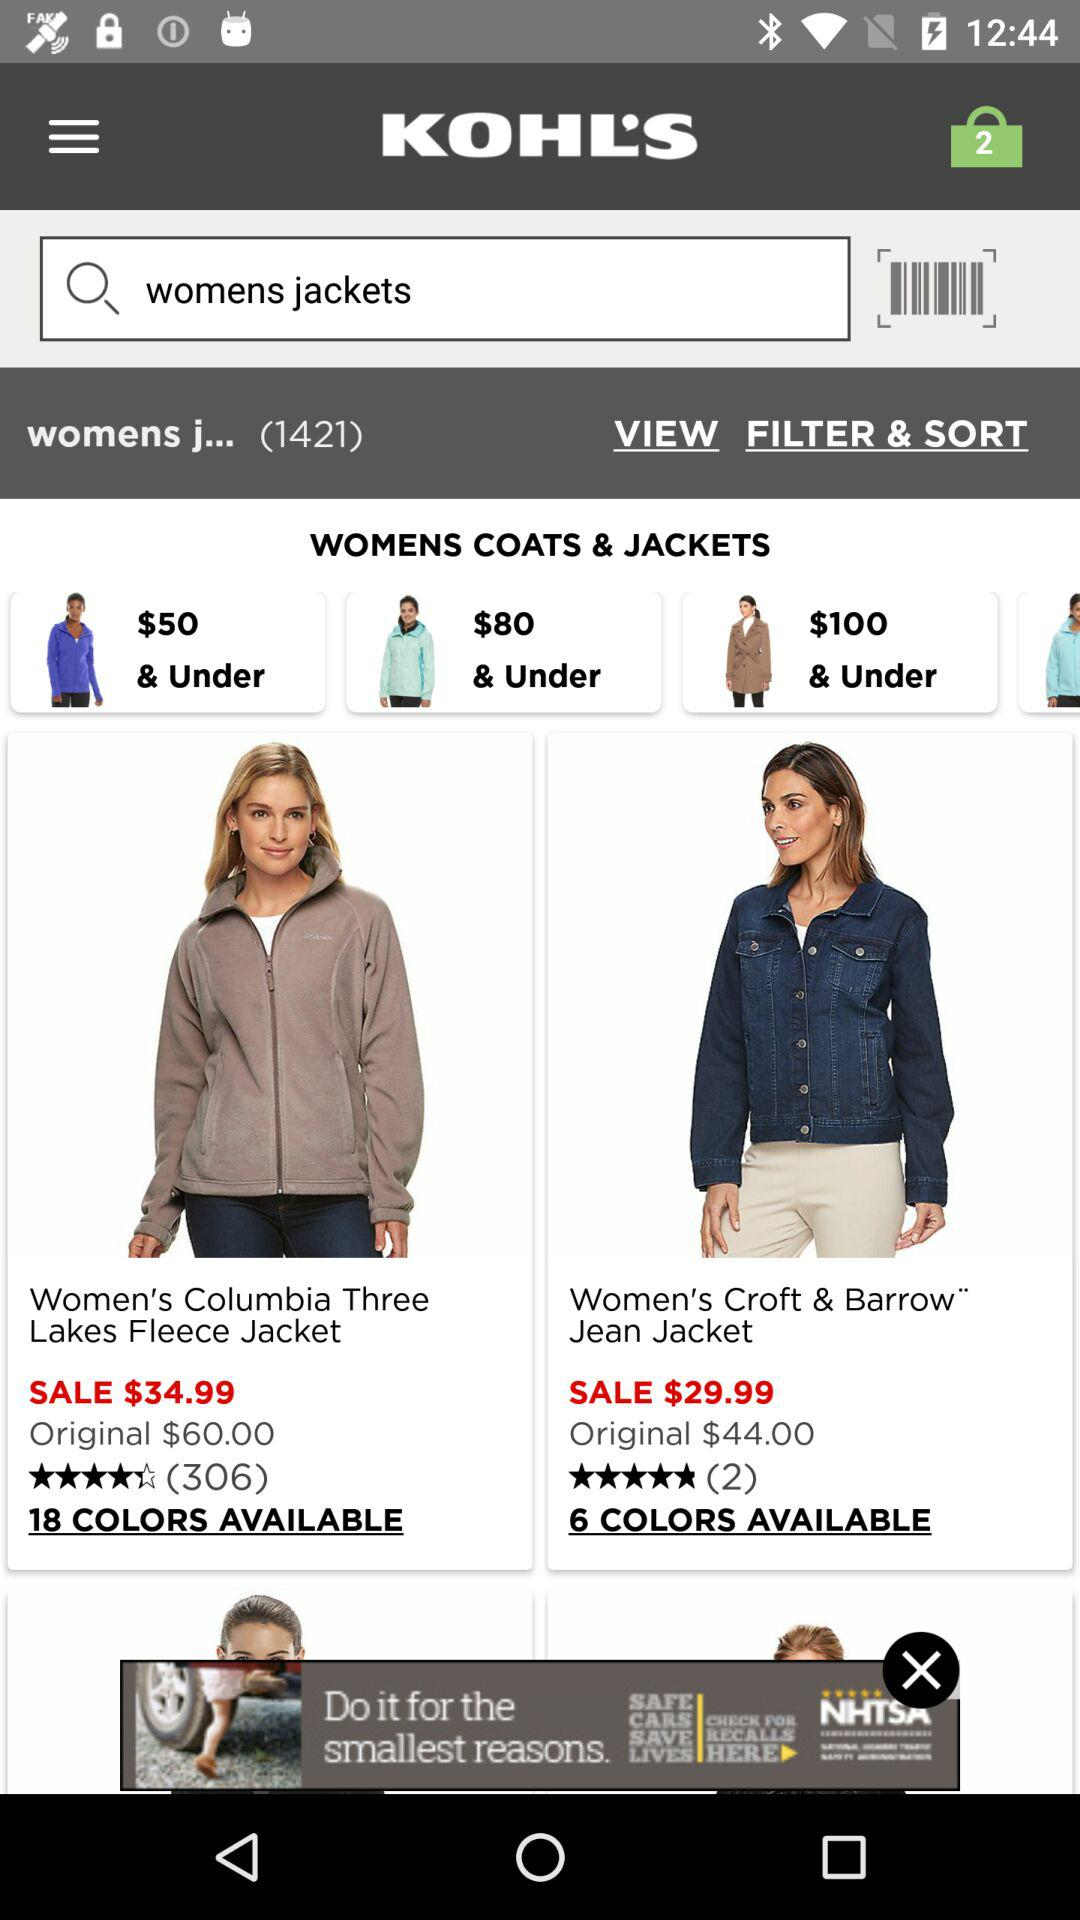What is the rating of women's croft and barrow jacket?
When the provided information is insufficient, respond with <no answer>. <no answer> 